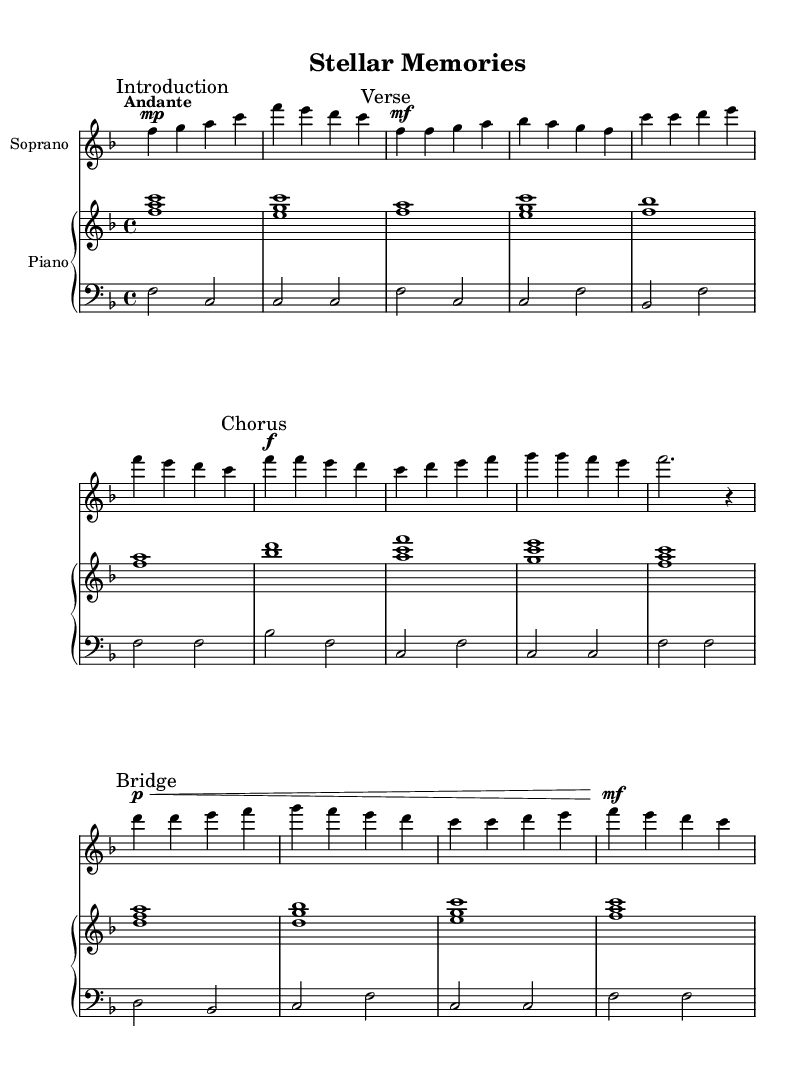What is the key signature of this music? The key signature displayed is F major, indicating one flat (B flat). This can be inferred from the key signature symbols at the beginning of the staff in the sheet music.
Answer: F major What is the time signature of this music? The time signature shown is 4/4, meaning there are four beats in each measure and the quarter note gets one beat. This is indicated by the notation at the beginning of the score.
Answer: 4/4 What is the tempo marking for this piece? The tempo marking provided is "Andante," which indicates a moderate pace. This information is usually noted at the beginning of the score, right under the title or in the 'global' section.
Answer: Andante How many verses are there in the vocal part? In the score, there is one verse section labeled "Verse," with lyrics corresponding to the melody written for that section. This is indicated by the marks in the soprano part, which signifies a single verse structure.
Answer: One What dynamic markings are present in the soprano part? The soprano part contains markings such as "mp" for mezzo-piano and "mf" for mezzo-forte, indicating the volume level at which the singer should perform. These dynamics are written directly above the notes.
Answer: mp, mf What is the lyrical theme of the piece? The lyrics speak about celestial bodies, specifically referencing Orion and the awe of the night sky, which can be inferred from the opening lines relating to starry nights and celestial wonders. The theme associates with the beauty and guidance of stars.
Answer: Celestial bodies Describe the structure of the aria. The aria consists of an introduction, a verse, a chorus, and a bridge, as indicated by the marked sections in the score. Each section represents a different part of the composition, showcasing both melodic progression and lyrical development.
Answer: Introduction, Verse, Chorus, Bridge 